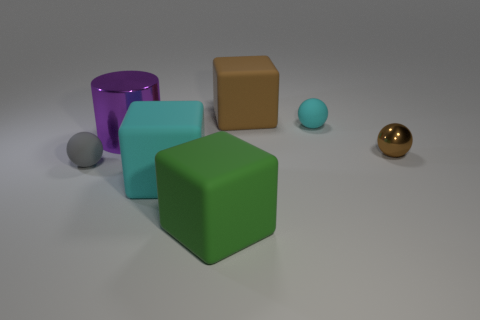Add 1 big rubber blocks. How many objects exist? 8 Subtract all big green matte cubes. How many cubes are left? 2 Subtract all green blocks. How many blocks are left? 2 Subtract 2 cubes. How many cubes are left? 1 Subtract all brown balls. Subtract all large green blocks. How many objects are left? 5 Add 5 green rubber blocks. How many green rubber blocks are left? 6 Add 6 small purple cubes. How many small purple cubes exist? 6 Subtract 1 green blocks. How many objects are left? 6 Subtract all cubes. How many objects are left? 4 Subtract all gray cylinders. Subtract all purple cubes. How many cylinders are left? 1 